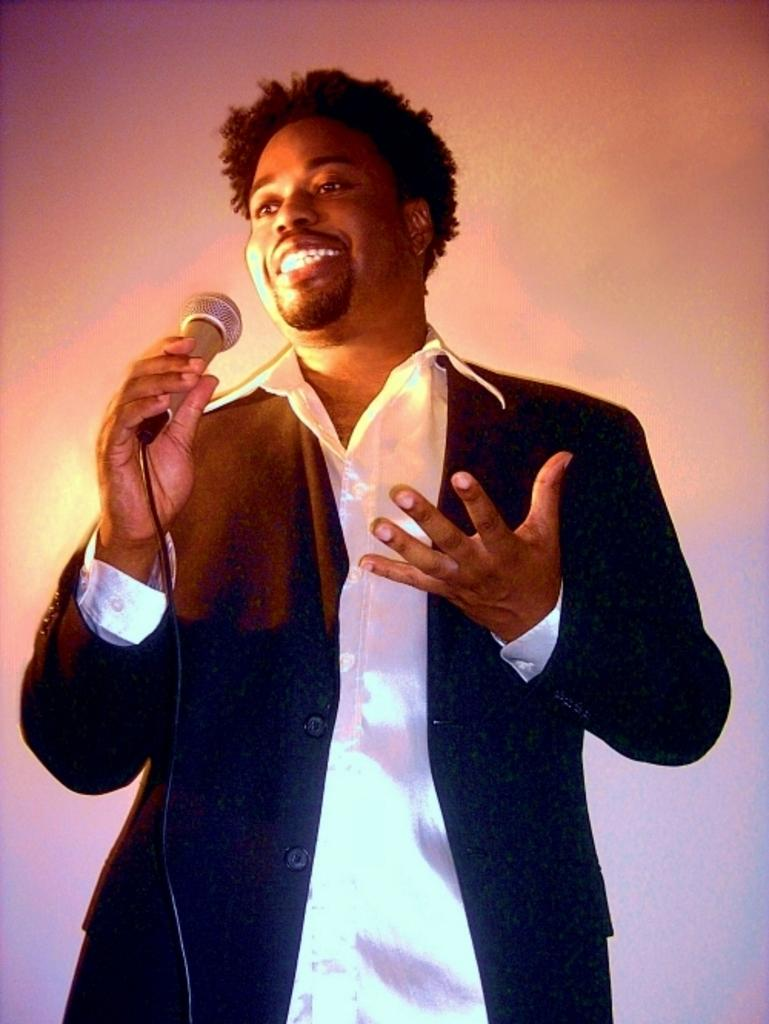Who is present in the image? There is a person in the image. What is the person wearing? The person is wearing a suit. What object is the person holding in their hands? The person is holding a microphone in their hands. What type of hydrant can be seen in the background of the image? There is no hydrant present in the image. How many arms does the person have in the image? The person has two arms, as is typical for humans. 